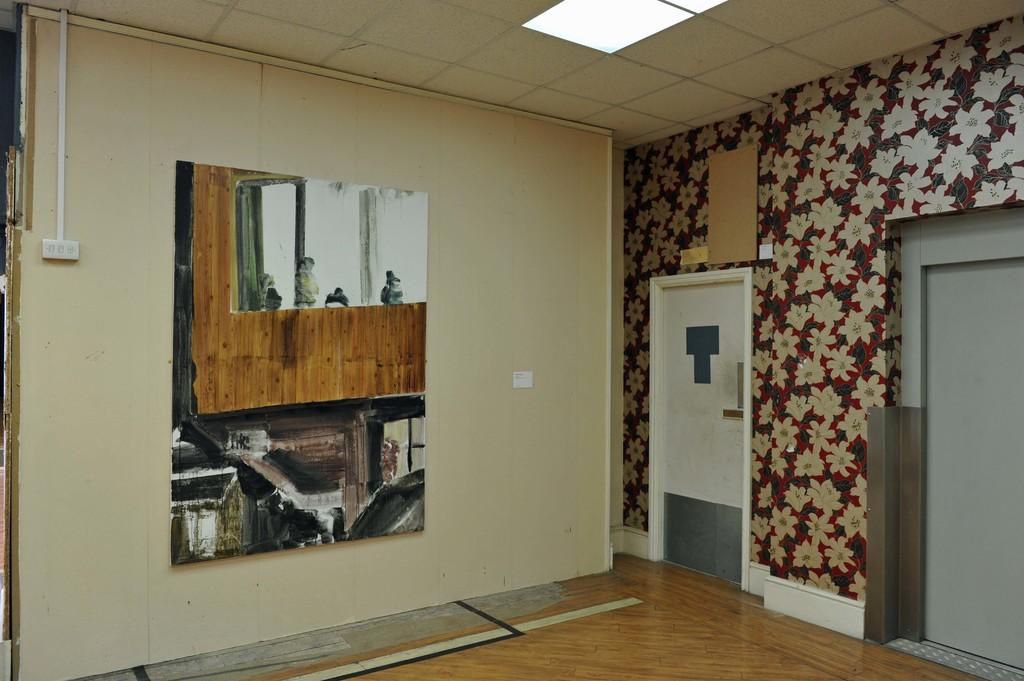What type of space is shown in the image? The image depicts a room. What is one of the main features of a room? There is a door in the room. What surrounds the room? There are walls in the room. What material is the floor made of? The floor in the room is made of wood. What is used to control the lighting in the room? There is a switchboard in the room. What provides illumination in the room? There is a light in the room. What decorative element can be seen on the wall? There is a painting on the wall. Can you hear the horn of a passing boat in the image? There is no reference to a boat or a horn in the image, so it is not possible to hear any sounds. 